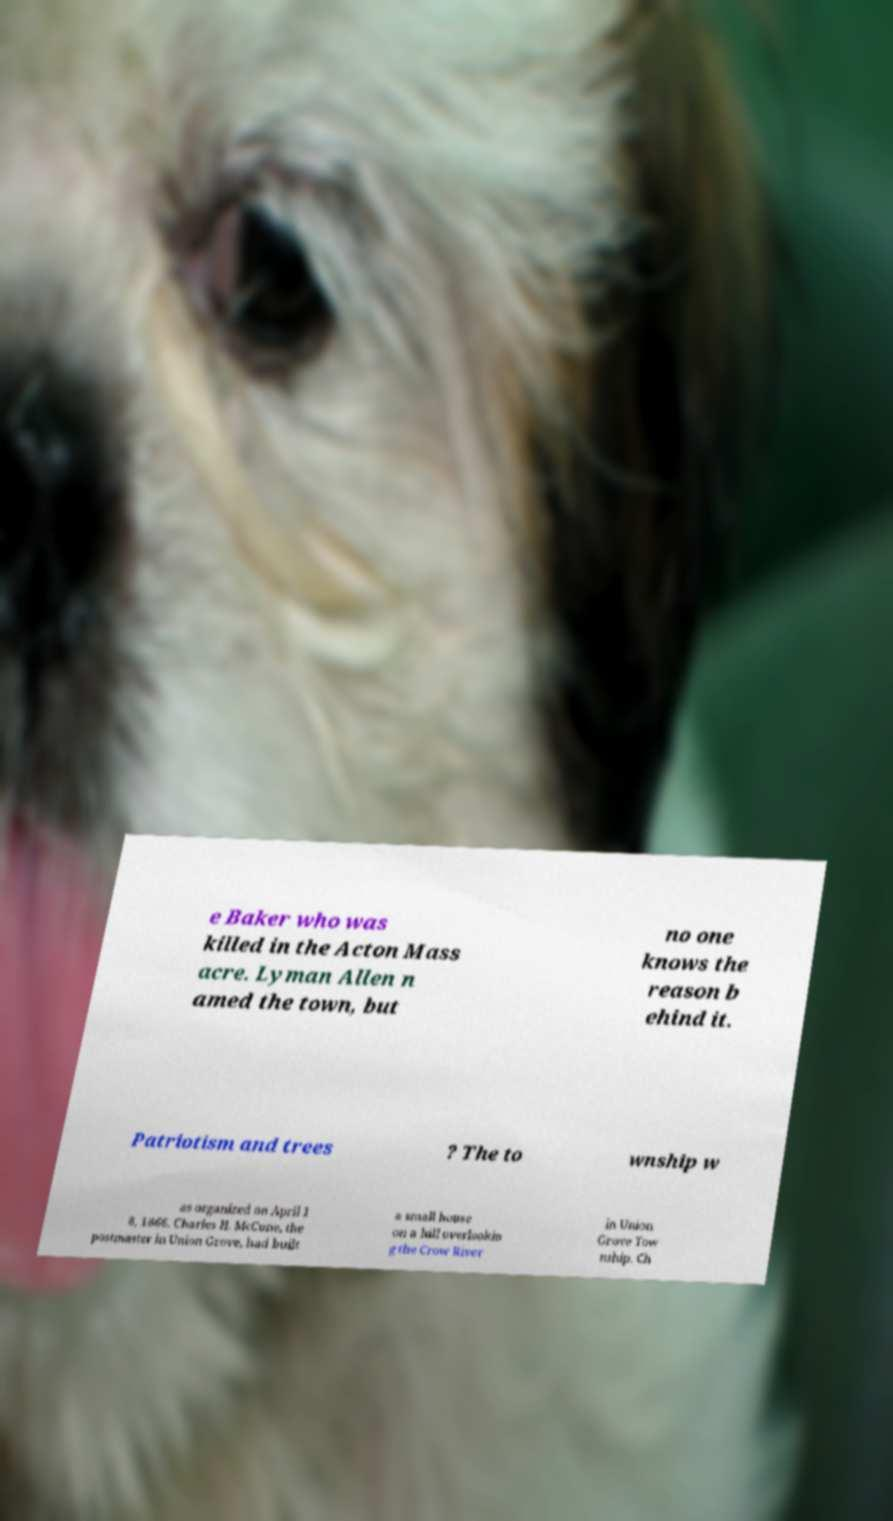Please read and relay the text visible in this image. What does it say? e Baker who was killed in the Acton Mass acre. Lyman Allen n amed the town, but no one knows the reason b ehind it. Patriotism and trees ? The to wnship w as organized on April 1 8, 1866. Charles H. McCune, the postmaster in Union Grove, had built a small house on a hill overlookin g the Crow River in Union Grove Tow nship. Ch 